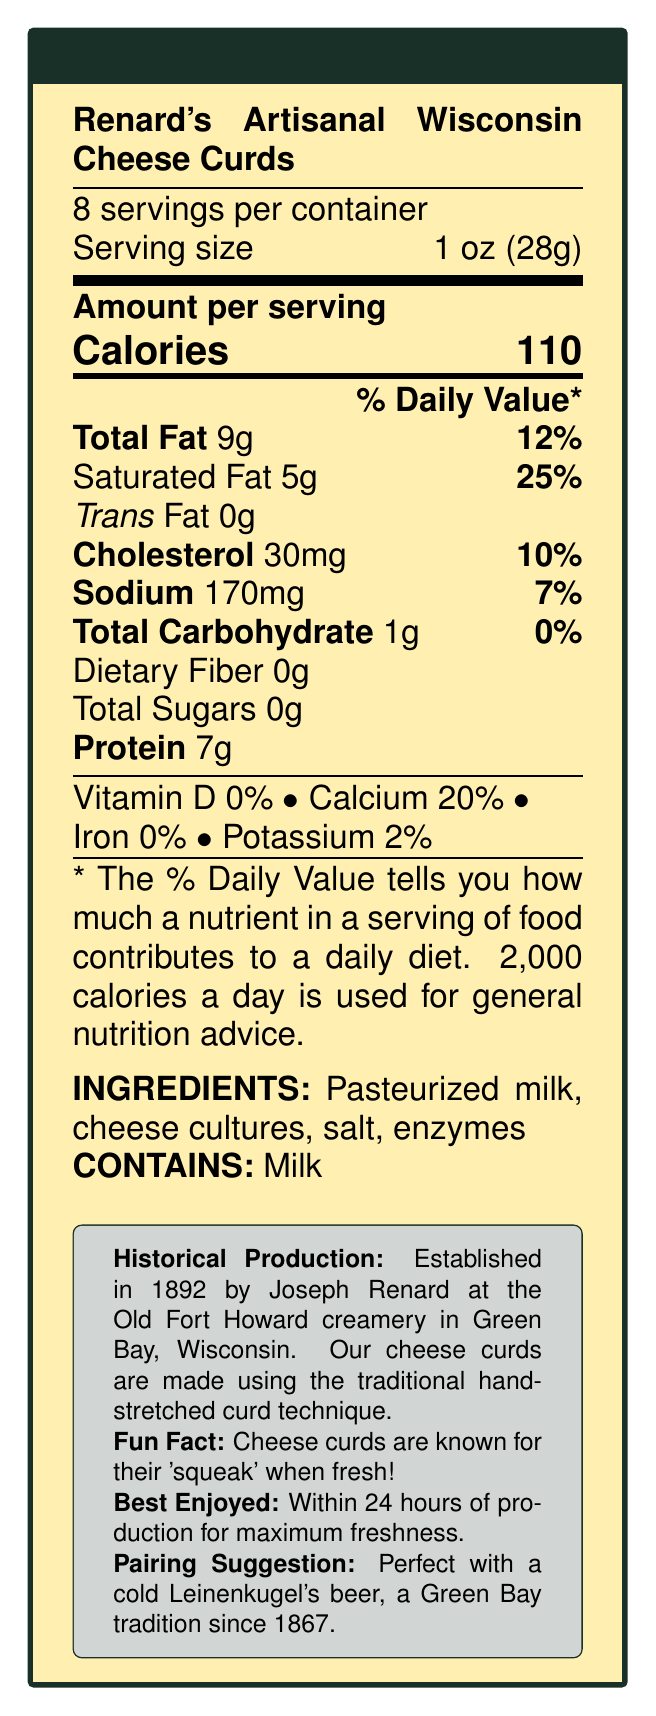what is the product name? The product name is stated at the top of the document under the title "Nutrition Facts".
Answer: Renard's Artisanal Wisconsin Cheese Curds how many servings are in a container? The document specifies "8 servings per container" in the first section after the product name.
Answer: 8 what is the serving size? The serving size is given as "1 oz (28g)" in the same line as "8 servings per container".
Answer: 1 oz (28g) how many calories per serving? The number of calories per serving is indicated in large bold text: "Calories 110".
Answer: 110 what percentage of daily value is the total fat per serving? The percentage of daily value for total fat is stated as "12%" next to "Total Fat 9g".
Answer: 12% who established Renard's cheese curds and when? The historical production section notes that the cheese curds were established by Joseph Renard in 1892.
Answer: Joseph Renard, 1892 what is a fun fact about cheese curds from the document? The fun fact section states that cheese curds are known for their 'squeak' when fresh.
Answer: Cheese curds are known for their 'squeak' when fresh what are the main ingredients of Renard's cheese curds? The ingredients are listed under the "INGREDIENTS" section.
Answer: Pasteurized milk, cheese cultures, salt, enzymes how should the cheese curds be stored for best quality? The document advises to "Keep refrigerated" for storage.
Answer: Keep refrigerated what is the best way to enjoy Renard's cheese curds according to the document? The document specifies that the cheese curds are best enjoyed "within 24 hours of production for maximum freshness".
Answer: Within 24 hours of production for maximum freshness which of the following nutrients has the highest percentage daily value per serving? a. Protein b. Calcium c. Sodium d. Saturated Fat Saturated fat has the highest percentage daily value at 25%, compared to protein (no daily value stated), calcium (20%), and sodium (7%).
Answer: d. Saturated Fat where was the original location of Renard's cheese curds production? a. Old Fort Howard creamery b. Green Bay cheese factory c. Renard's family farm d. Wisconsin dairy farms The historical production section mentions that the original location was Old Fort Howard creamery.
Answer: a. Old Fort Howard creamery does the product contain any allergen information? The document indicates "CONTAINS: Milk" under the allergen information.
Answer: Yes summarize the main nutritional characteristics and historical context of Renard's Artisanal Wisconsin Cheese Curds. This summary captures the main nutritional components, historical background, and fun facts mentioned in the document.
Answer: Renard's Artisanal Wisconsin Cheese Curds have 110 calories per serving, with notable amounts of total fat (9g, 12% DV), saturated fat (5g, 25% DV), cholesterol (30mg, 10% DV), sodium (170mg, 7% DV), and protein (7g). The cheese curds originated in Green Bay, Wisconsin, established by Joseph Renard in 1892 at the Old Fort Howard creamery, utilizing traditional hand-stretched curd techniques. They are best enjoyed fresh within 24 hours and are traditionally paired with a cold Leinenkugel's beer. what is the best beer pairing suggestion for these cheese curds? The pairing suggestion states, "Perfect with a cold Leinenkugel's beer".
Answer: Leinenkugel's beer what is the daily value percentage of potassium per serving? The document provides the daily value for potassium as 2%.
Answer: 2% describe the traditional method used to produce these cheese curds. The document mentions the traditional hand-stretched curd technique under the historical production section.
Answer: Hand-stretched curd technique how much total carbohydrate is in one serving? The total carbohydrate content per serving is listed as 1g.
Answer: 1g are cheese curds best enjoyed within 48 hours of production? The document states that cheese curds are best enjoyed within 24 hours of production for maximum freshness.
Answer: No who was Green Bay's first cheese factory opened by? The document only mentions that Green Bay's first cheese factory opened in 1873 but does not specify who opened it.
Answer: Not enough information 